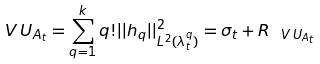Convert formula to latex. <formula><loc_0><loc_0><loc_500><loc_500>\ V \, U _ { A _ { t } } = \sum _ { q = 1 } ^ { k } q ! | | h _ { q } | | _ { L ^ { 2 } ( \lambda _ { t } ^ { q } ) } ^ { 2 } = \sigma _ { t } + R _ { \ V \, U _ { A _ { t } } }</formula> 